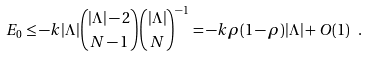Convert formula to latex. <formula><loc_0><loc_0><loc_500><loc_500>E _ { 0 } \leq - k | \Lambda | { | \Lambda | - 2 \choose N - 1 } { | \Lambda | \choose N } ^ { - 1 } = - k \rho ( 1 - \rho ) | \Lambda | + O ( 1 ) \ .</formula> 